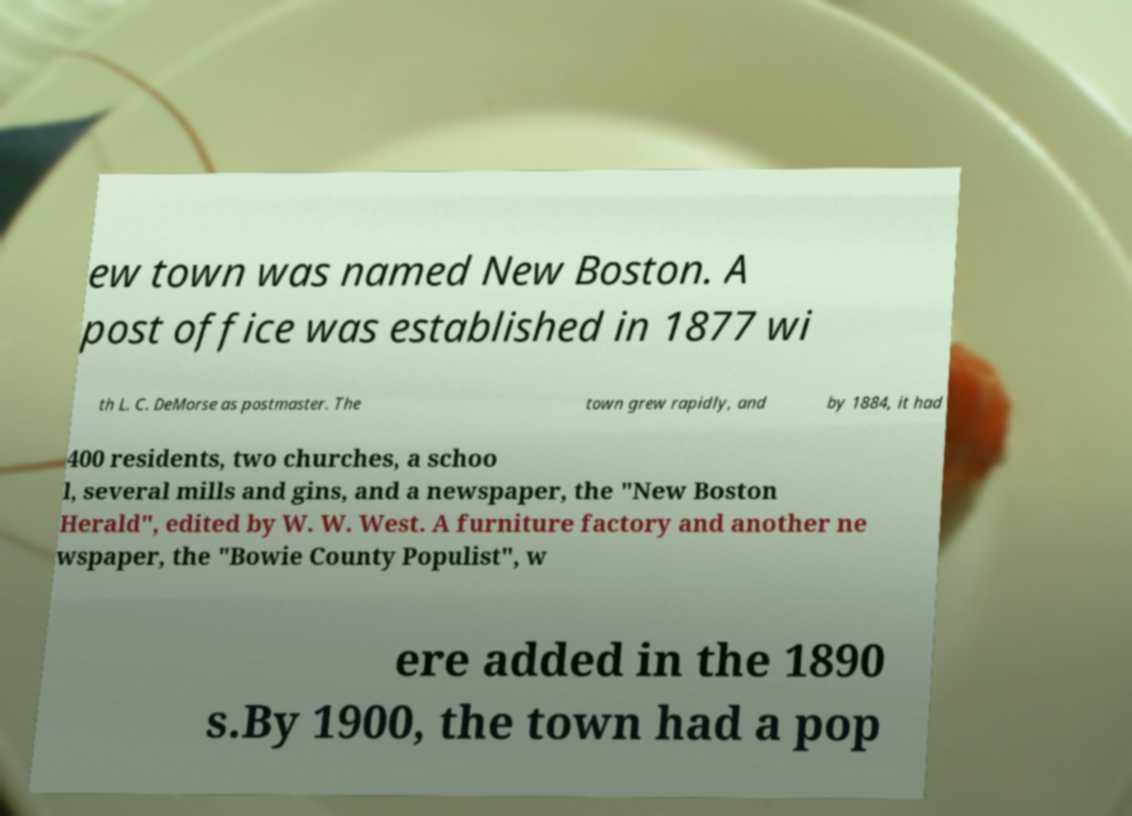I need the written content from this picture converted into text. Can you do that? ew town was named New Boston. A post office was established in 1877 wi th L. C. DeMorse as postmaster. The town grew rapidly, and by 1884, it had 400 residents, two churches, a schoo l, several mills and gins, and a newspaper, the "New Boston Herald", edited by W. W. West. A furniture factory and another ne wspaper, the "Bowie County Populist", w ere added in the 1890 s.By 1900, the town had a pop 